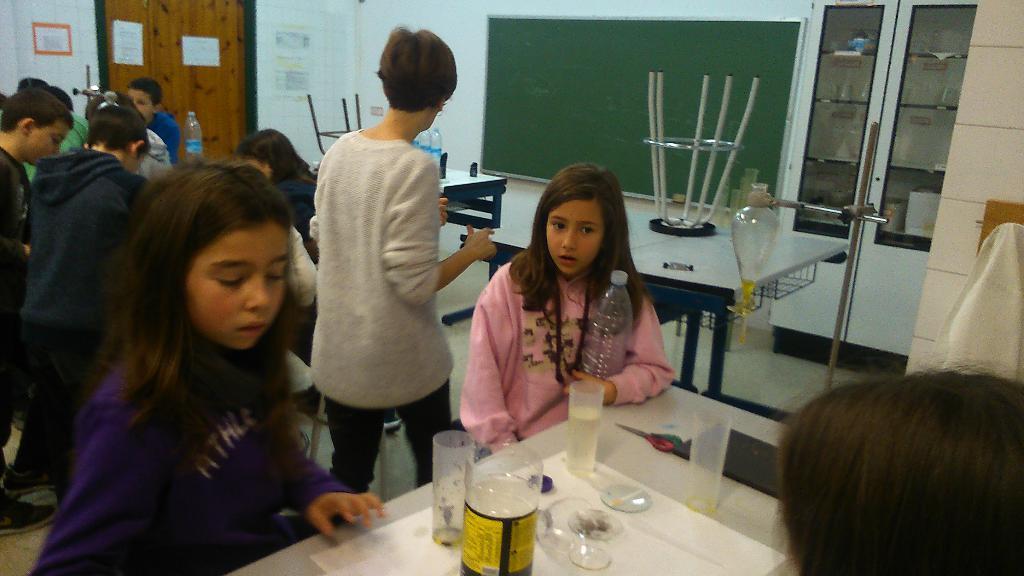Could you give a brief overview of what you see in this image? In the background we can see posters, wall. In this picture we can see a stool placed on a table. We can see a green board, tables, bottles, objects, cupboards and the floor. We can see people standing. In the bottom right corner of the picture on a table we can see glasses and few objects. We can see a girl holding a bottle. 